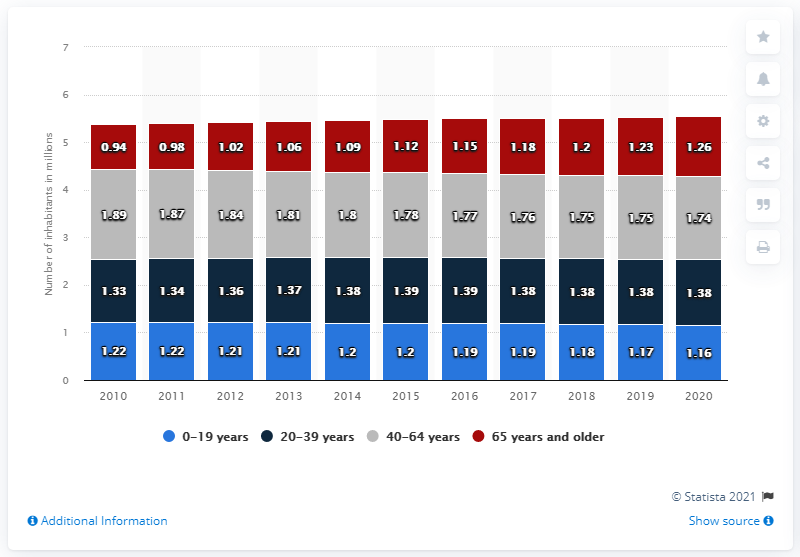Identify some key points in this picture. In 2020, there were approximately 1.26 million people aged 65 and older in Finland. 